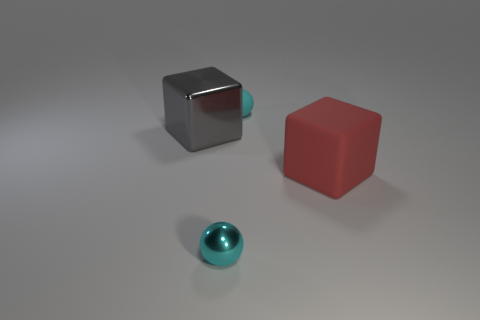Subtract all gray spheres. Subtract all brown cubes. How many spheres are left? 2 Add 1 yellow shiny balls. How many objects exist? 5 Add 4 shiny objects. How many shiny objects are left? 6 Add 1 yellow shiny cubes. How many yellow shiny cubes exist? 1 Subtract 0 yellow cubes. How many objects are left? 4 Subtract all big gray cubes. Subtract all large red blocks. How many objects are left? 2 